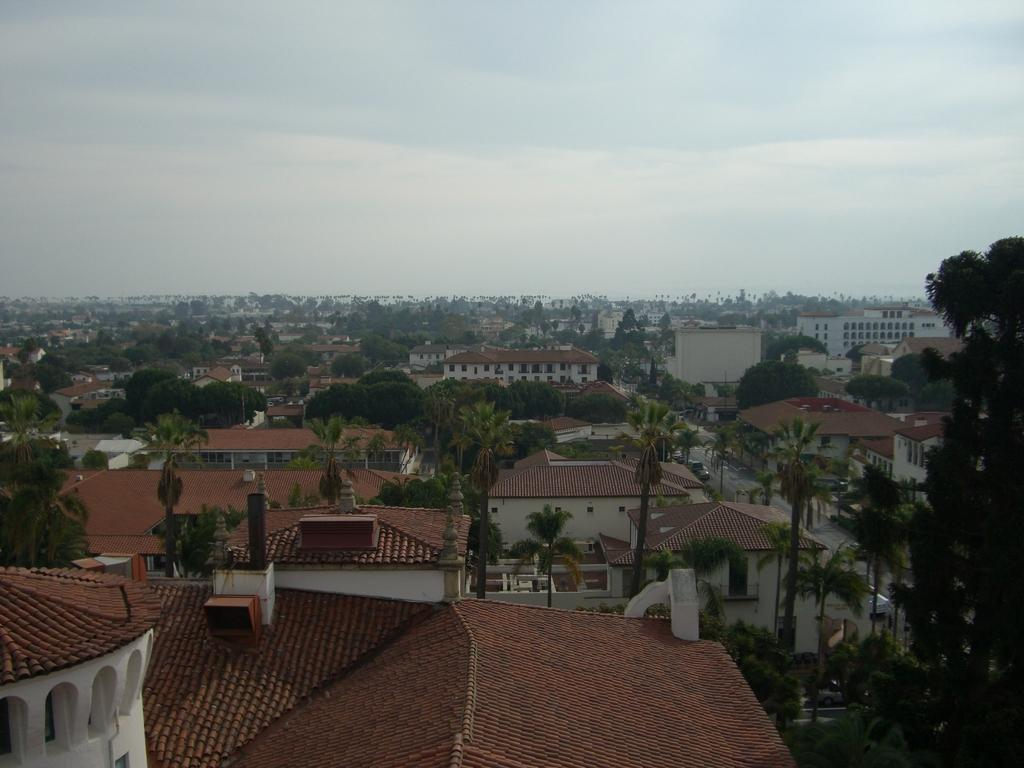What type of structures can be seen in the image? There are houses and buildings in the image. What type of vegetation is present in the image? There are trees in the image. What is visible in the background of the image? The sky is visible in the background of the image. What can be seen in the sky? There are clouds in the sky. What action is the existence performing with its partner in the image? There is no action or existence present in the image; it features houses, buildings, trees, and clouds. 